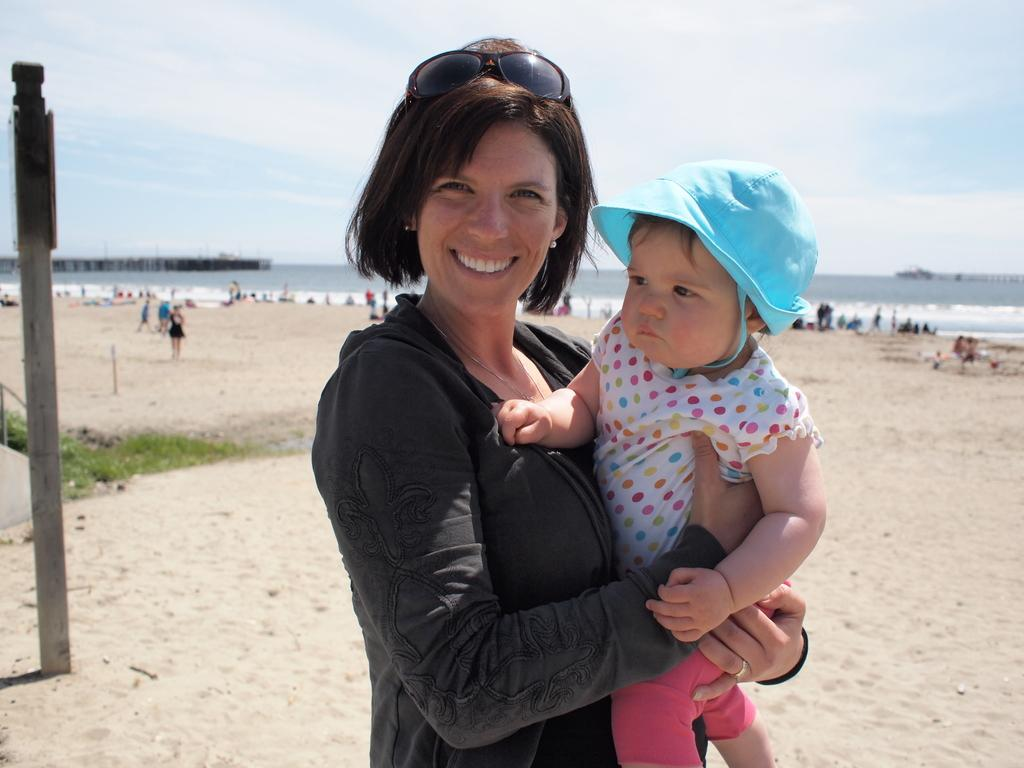What is the person in the image holding? The person is holding a baby in the image. Can you describe the scene in the background of the image? There are people, water, a pole, and the sky visible in the background of the image. How many people are present in the image? There is at least one person holding a baby, and there are people in the background, so there are multiple people in the image. Where is the kitten performing on the stage in the image? There is no kitten or stage present in the image. What type of owl can be seen flying in the sky in the image? There are no owls visible in the sky in the image. 